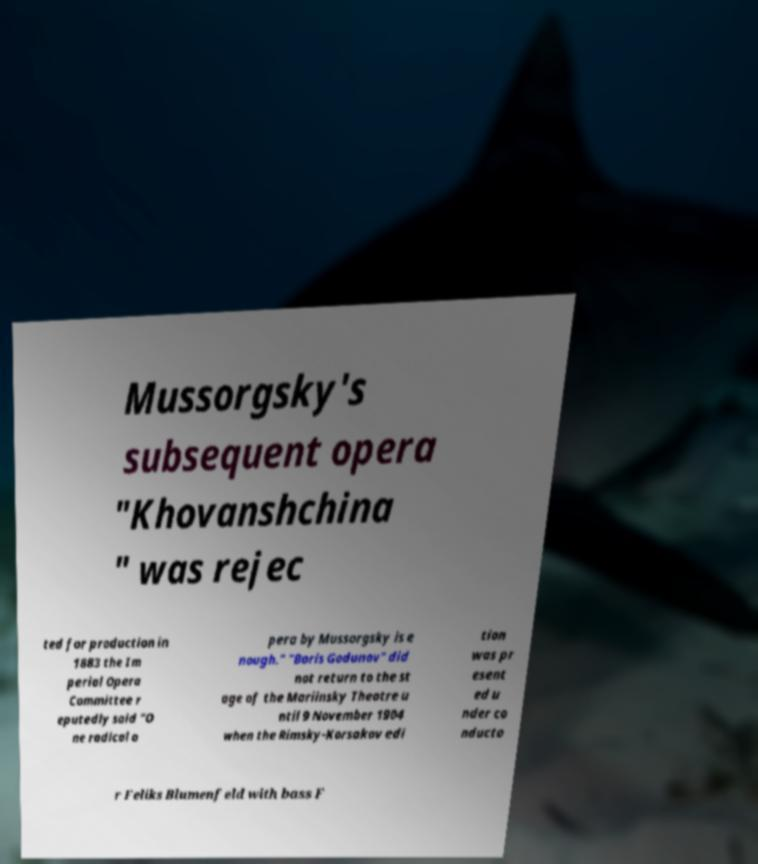Could you assist in decoding the text presented in this image and type it out clearly? Mussorgsky's subsequent opera "Khovanshchina " was rejec ted for production in 1883 the Im perial Opera Committee r eputedly said "O ne radical o pera by Mussorgsky is e nough." "Boris Godunov" did not return to the st age of the Mariinsky Theatre u ntil 9 November 1904 when the Rimsky-Korsakov edi tion was pr esent ed u nder co nducto r Feliks Blumenfeld with bass F 